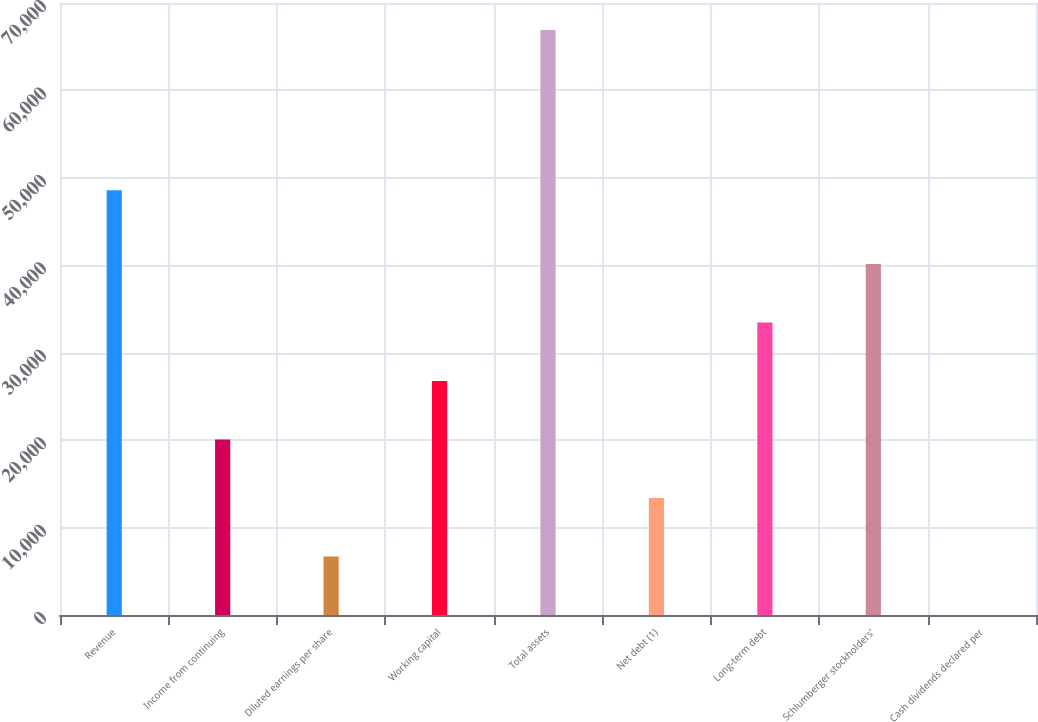<chart> <loc_0><loc_0><loc_500><loc_500><bar_chart><fcel>Revenue<fcel>Income from continuing<fcel>Diluted earnings per share<fcel>Working capital<fcel>Total assets<fcel>Net debt (1)<fcel>Long-term debt<fcel>Schlumberger stockholders'<fcel>Cash dividends declared per<nl><fcel>48580<fcel>20072.3<fcel>6691.84<fcel>26762.6<fcel>66904<fcel>13382.1<fcel>33452.8<fcel>40143<fcel>1.6<nl></chart> 